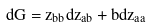Convert formula to latex. <formula><loc_0><loc_0><loc_500><loc_500>d G = z _ { b b } d z _ { a b } + b d z _ { a a }</formula> 